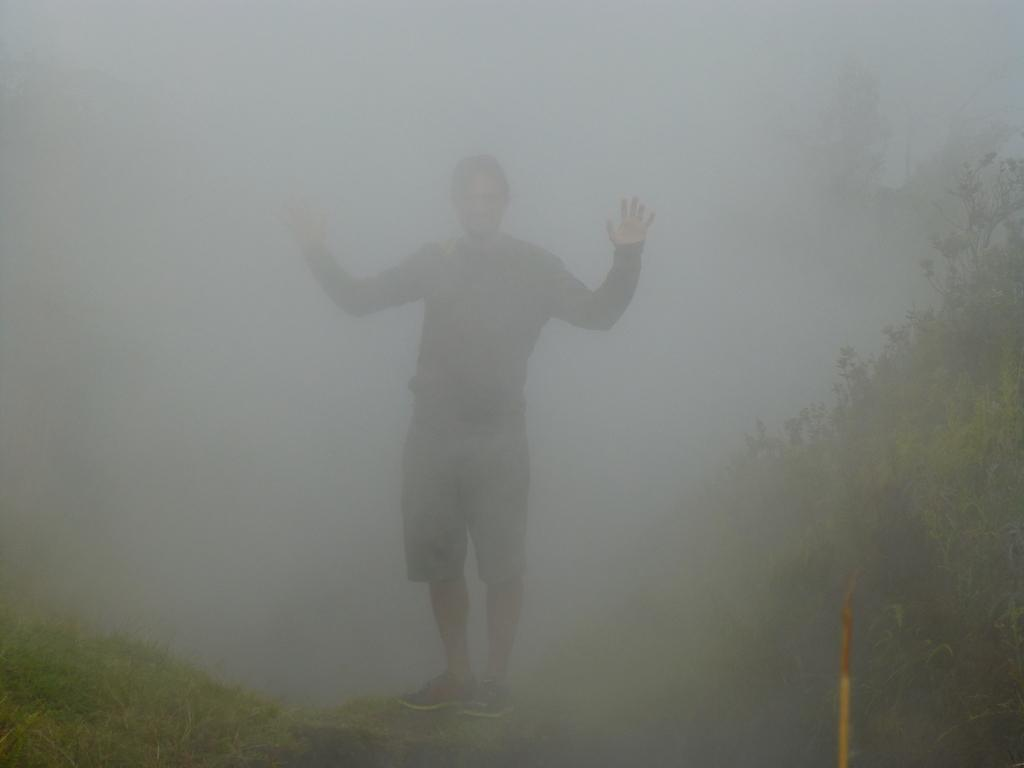What is the main subject of the image? There is a person standing in the center of the image. What type of surface is visible at the bottom of the image? There is grass at the bottom of the image. What book is the person reading in the image? There is no book present in the image; the person is standing, not reading. 